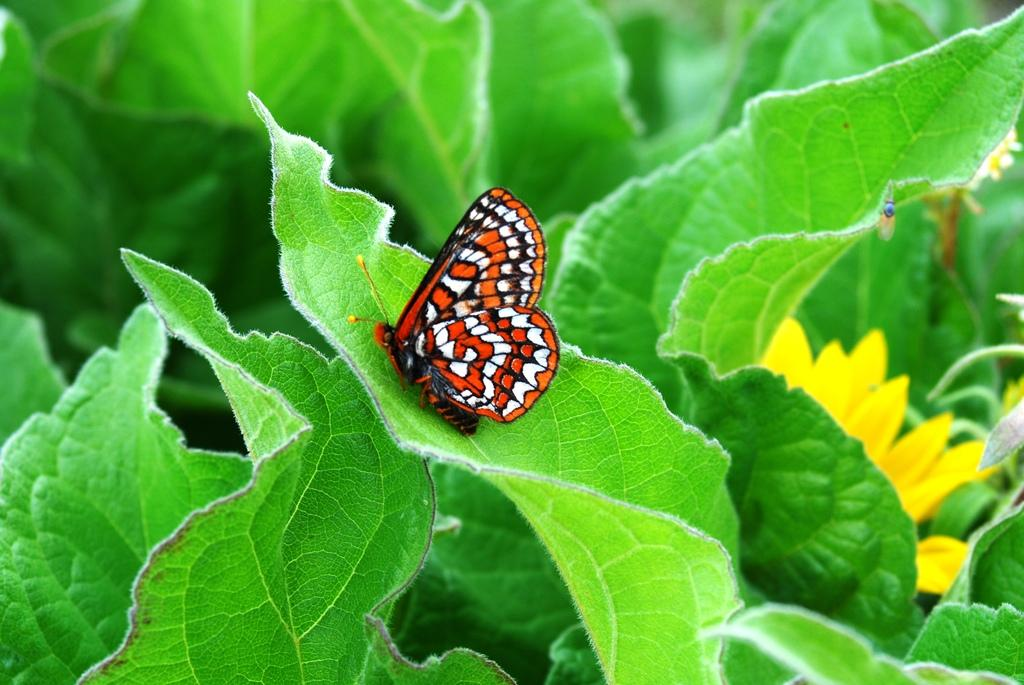What is the main subject of the image? There is a butterfly in the image. What is the butterfly doing in the image? The butterfly is laying on a leaf. What can be seen around the leaf with the butterfly? There are many other leaves surrounding the leaf with the butterfly. Is there any smoke visible in the image? No, there is no smoke present in the image. What type of slope can be seen in the image? There is no slope present in the image; it features a butterfly laying on a leaf surrounded by other leaves. 